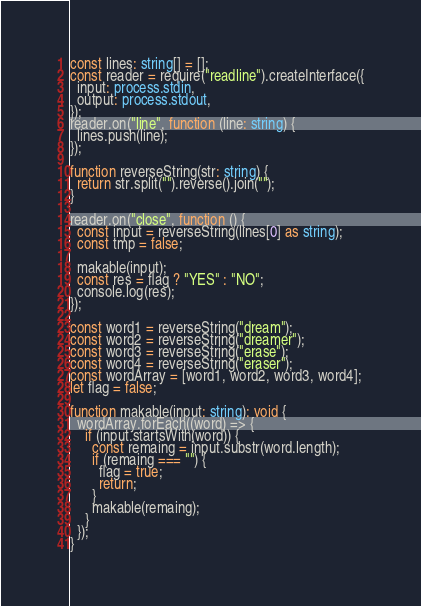Convert code to text. <code><loc_0><loc_0><loc_500><loc_500><_TypeScript_>const lines: string[] = [];
const reader = require("readline").createInterface({
  input: process.stdin,
  output: process.stdout,
});
reader.on("line", function (line: string) {
  lines.push(line);
});

function reverseString(str: string) {
  return str.split("").reverse().join("");
}

reader.on("close", function () {
  const input = reverseString(lines[0] as string);
  const tmp = false;

  makable(input);
  const res = flag ? "YES" : "NO";
  console.log(res);
});

const word1 = reverseString("dream");
const word2 = reverseString("dreamer");
const word3 = reverseString("erase");
const word4 = reverseString("eraser");
const wordArray = [word1, word2, word3, word4];
let flag = false;

function makable(input: string): void {
  wordArray.forEach((word) => {
    if (input.startsWith(word)) {
      const remaing = input.substr(word.length);
      if (remaing === "") {
        flag = true;
        return;
      }
      makable(remaing);
    }
  });
}
</code> 